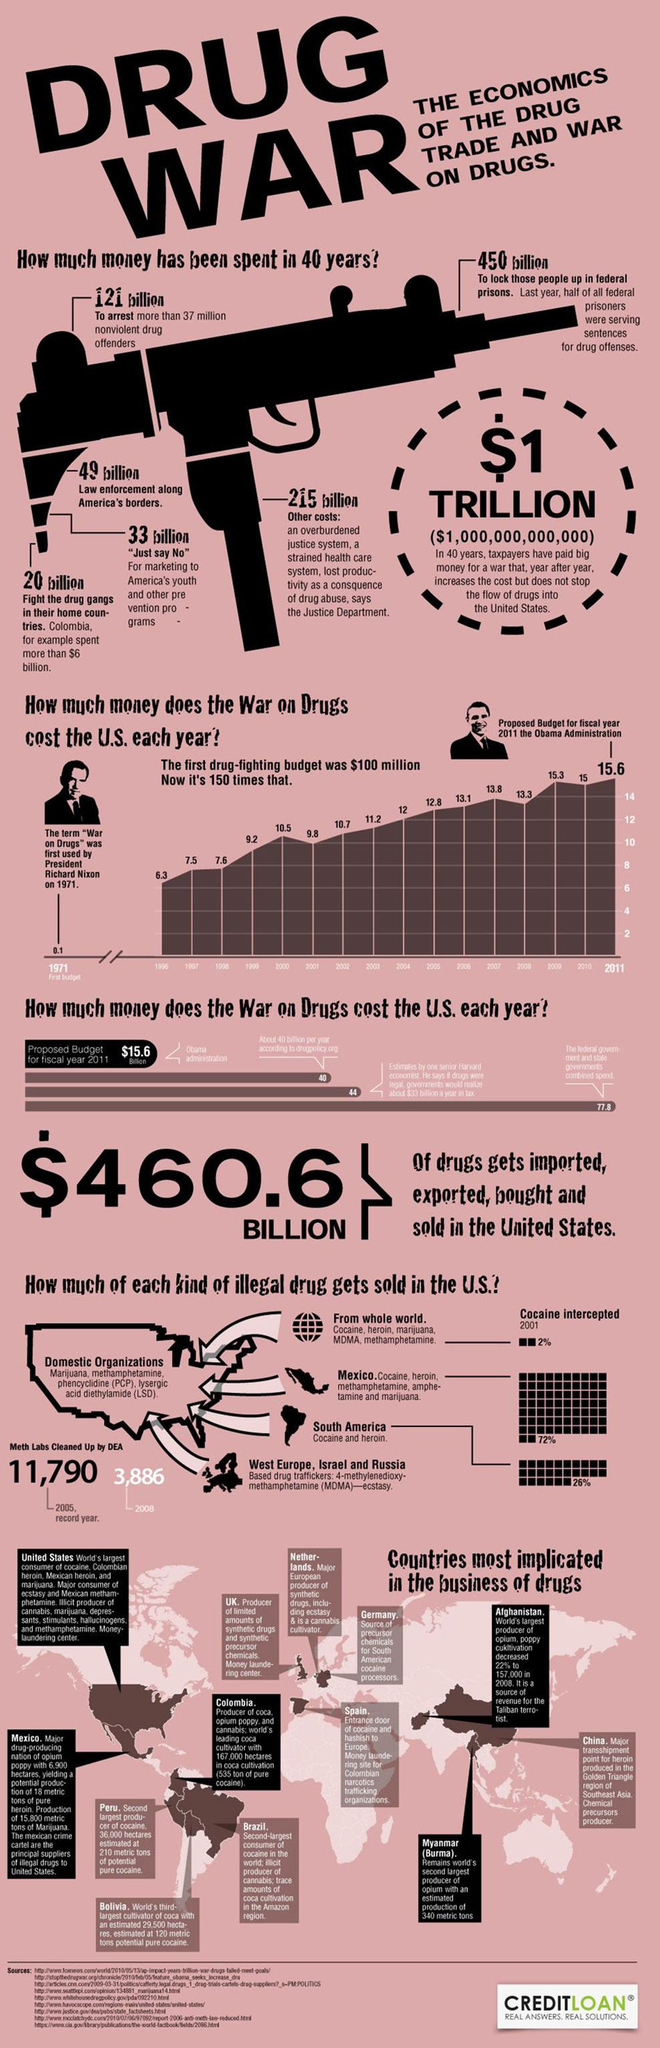List a handful of essential elements in this visual. Colombia is the country that leads in the production of Coca. According to data from 2002 and 2011, the difference in the drug-fighting budget allocated was 5.1 million. The document provides images of Richard Nixon and Barack Obama, the past presidents of the United States of America. In the last forty years, the total expenses incurred in the fight against drug abuse amount to 888 billion. A significant percentage of drugs from South America are sold in the United States. According to recent data, 72% of these drugs are sold in the US, while only 2% are sold in other countries. 